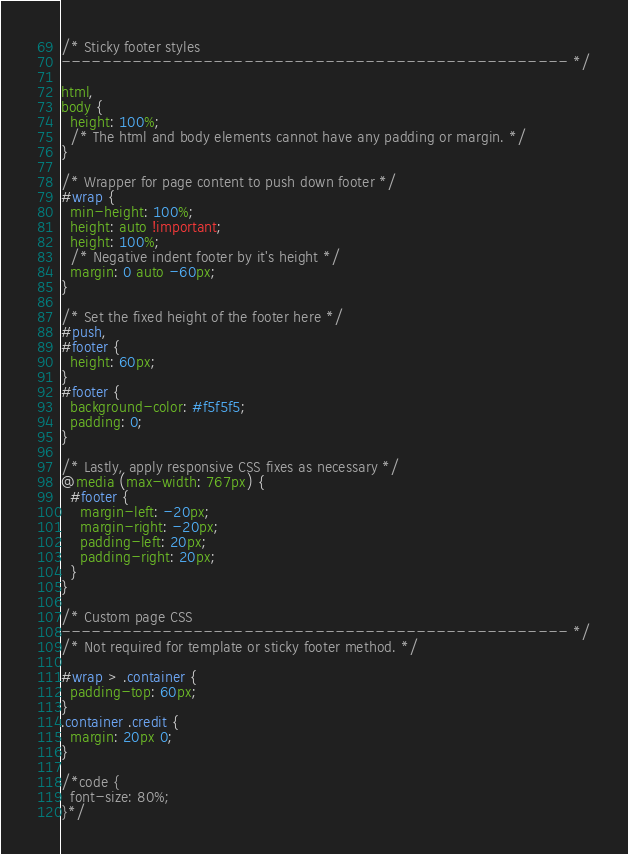Convert code to text. <code><loc_0><loc_0><loc_500><loc_500><_CSS_>/* Sticky footer styles
-------------------------------------------------- */

html,
body {
  height: 100%;
  /* The html and body elements cannot have any padding or margin. */
}

/* Wrapper for page content to push down footer */
#wrap {
  min-height: 100%;
  height: auto !important;
  height: 100%;
  /* Negative indent footer by it's height */
  margin: 0 auto -60px;
}

/* Set the fixed height of the footer here */
#push,
#footer {
  height: 60px;
}
#footer {
  background-color: #f5f5f5;
  padding: 0;
}

/* Lastly, apply responsive CSS fixes as necessary */
@media (max-width: 767px) {
  #footer {
    margin-left: -20px;
    margin-right: -20px;
    padding-left: 20px;
    padding-right: 20px;
  }
}

/* Custom page CSS
-------------------------------------------------- */
/* Not required for template or sticky footer method. */

#wrap > .container {
  padding-top: 60px;
}
.container .credit {
  margin: 20px 0;
}

/*code {
  font-size: 80%;
}*/</code> 